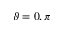Convert formula to latex. <formula><loc_0><loc_0><loc_500><loc_500>\vartheta = 0 , \pi</formula> 